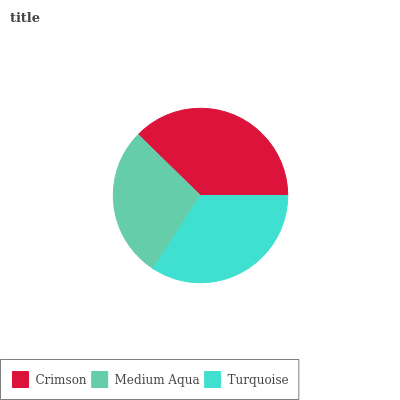Is Medium Aqua the minimum?
Answer yes or no. Yes. Is Crimson the maximum?
Answer yes or no. Yes. Is Turquoise the minimum?
Answer yes or no. No. Is Turquoise the maximum?
Answer yes or no. No. Is Turquoise greater than Medium Aqua?
Answer yes or no. Yes. Is Medium Aqua less than Turquoise?
Answer yes or no. Yes. Is Medium Aqua greater than Turquoise?
Answer yes or no. No. Is Turquoise less than Medium Aqua?
Answer yes or no. No. Is Turquoise the high median?
Answer yes or no. Yes. Is Turquoise the low median?
Answer yes or no. Yes. Is Medium Aqua the high median?
Answer yes or no. No. Is Medium Aqua the low median?
Answer yes or no. No. 